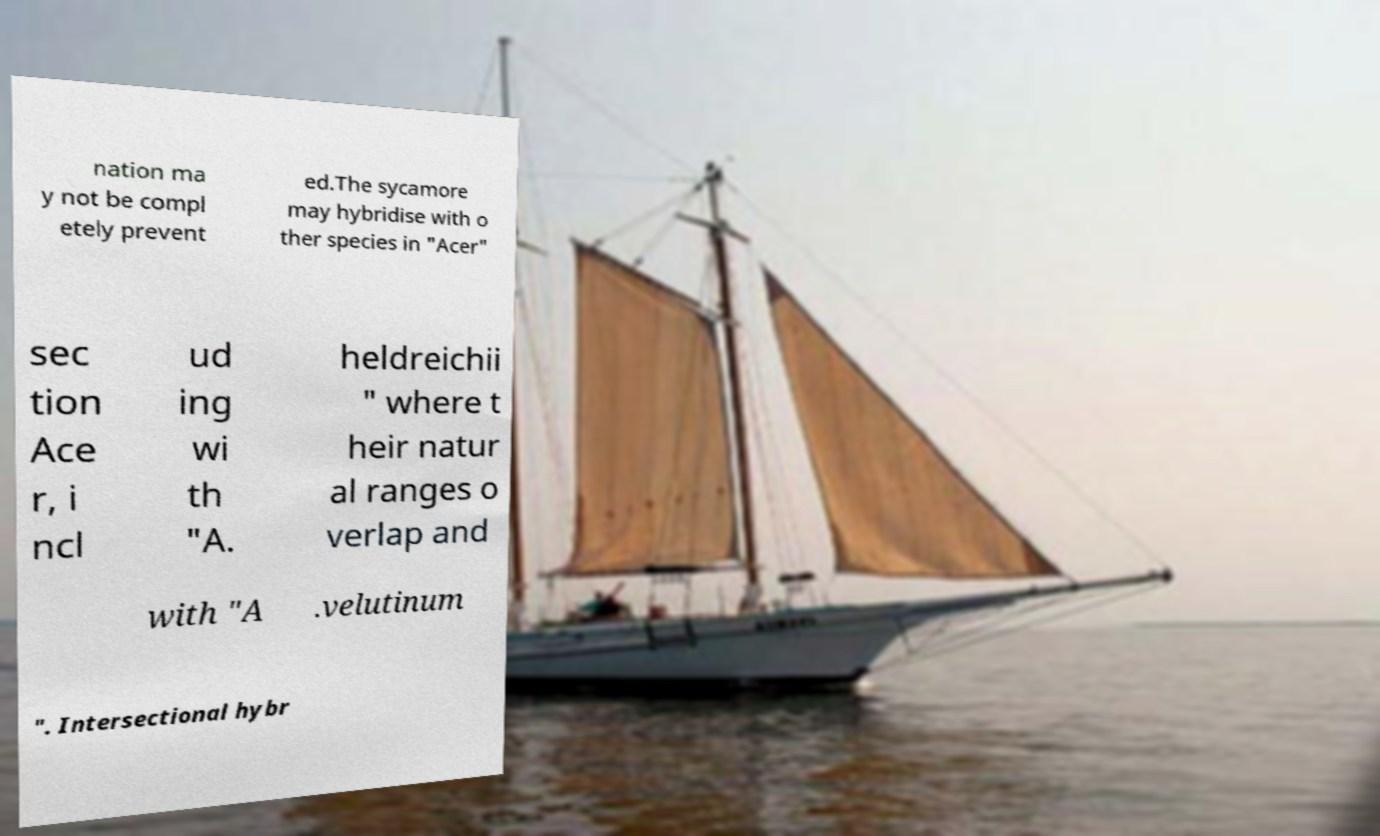Can you accurately transcribe the text from the provided image for me? nation ma y not be compl etely prevent ed.The sycamore may hybridise with o ther species in "Acer" sec tion Ace r, i ncl ud ing wi th "A. heldreichii " where t heir natur al ranges o verlap and with "A .velutinum ". Intersectional hybr 